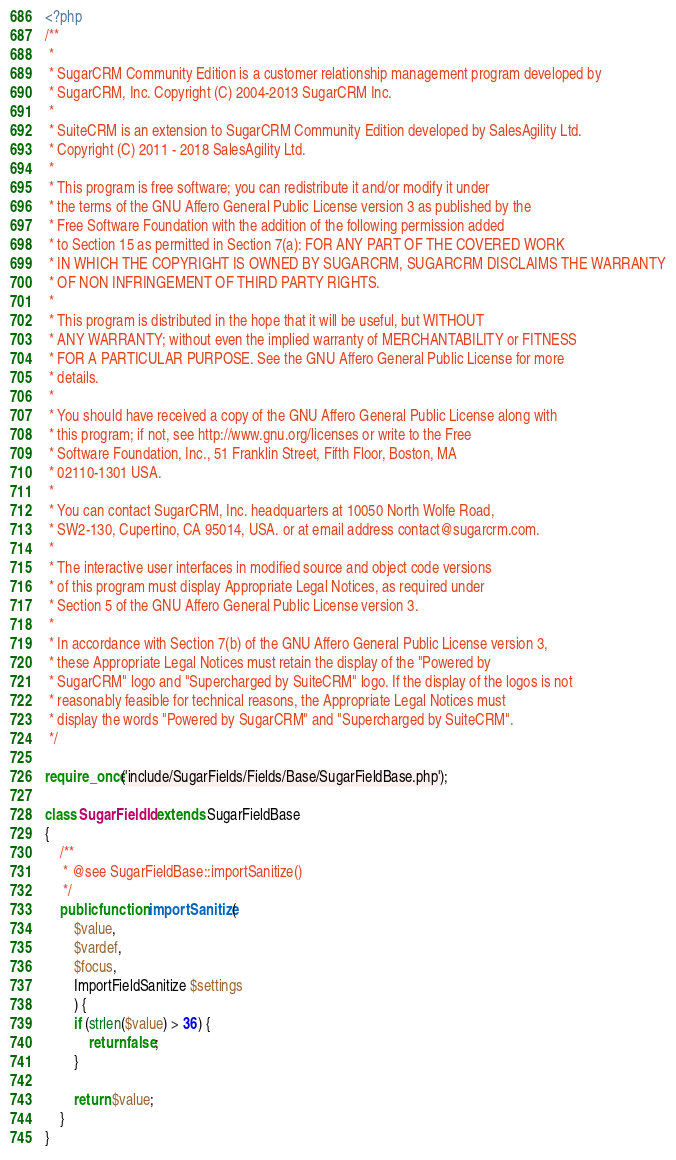<code> <loc_0><loc_0><loc_500><loc_500><_PHP_><?php
/**
 *
 * SugarCRM Community Edition is a customer relationship management program developed by
 * SugarCRM, Inc. Copyright (C) 2004-2013 SugarCRM Inc.
 *
 * SuiteCRM is an extension to SugarCRM Community Edition developed by SalesAgility Ltd.
 * Copyright (C) 2011 - 2018 SalesAgility Ltd.
 *
 * This program is free software; you can redistribute it and/or modify it under
 * the terms of the GNU Affero General Public License version 3 as published by the
 * Free Software Foundation with the addition of the following permission added
 * to Section 15 as permitted in Section 7(a): FOR ANY PART OF THE COVERED WORK
 * IN WHICH THE COPYRIGHT IS OWNED BY SUGARCRM, SUGARCRM DISCLAIMS THE WARRANTY
 * OF NON INFRINGEMENT OF THIRD PARTY RIGHTS.
 *
 * This program is distributed in the hope that it will be useful, but WITHOUT
 * ANY WARRANTY; without even the implied warranty of MERCHANTABILITY or FITNESS
 * FOR A PARTICULAR PURPOSE. See the GNU Affero General Public License for more
 * details.
 *
 * You should have received a copy of the GNU Affero General Public License along with
 * this program; if not, see http://www.gnu.org/licenses or write to the Free
 * Software Foundation, Inc., 51 Franklin Street, Fifth Floor, Boston, MA
 * 02110-1301 USA.
 *
 * You can contact SugarCRM, Inc. headquarters at 10050 North Wolfe Road,
 * SW2-130, Cupertino, CA 95014, USA. or at email address contact@sugarcrm.com.
 *
 * The interactive user interfaces in modified source and object code versions
 * of this program must display Appropriate Legal Notices, as required under
 * Section 5 of the GNU Affero General Public License version 3.
 *
 * In accordance with Section 7(b) of the GNU Affero General Public License version 3,
 * these Appropriate Legal Notices must retain the display of the "Powered by
 * SugarCRM" logo and "Supercharged by SuiteCRM" logo. If the display of the logos is not
 * reasonably feasible for technical reasons, the Appropriate Legal Notices must
 * display the words "Powered by SugarCRM" and "Supercharged by SuiteCRM".
 */

require_once('include/SugarFields/Fields/Base/SugarFieldBase.php');

class SugarFieldId extends SugarFieldBase
{
    /**
     * @see SugarFieldBase::importSanitize()
     */
    public function importSanitize(
        $value,
        $vardef,
        $focus,
        ImportFieldSanitize $settings
        ) {
        if (strlen($value) > 36) {
            return false;
        }
        
        return $value;
    }
}
</code> 